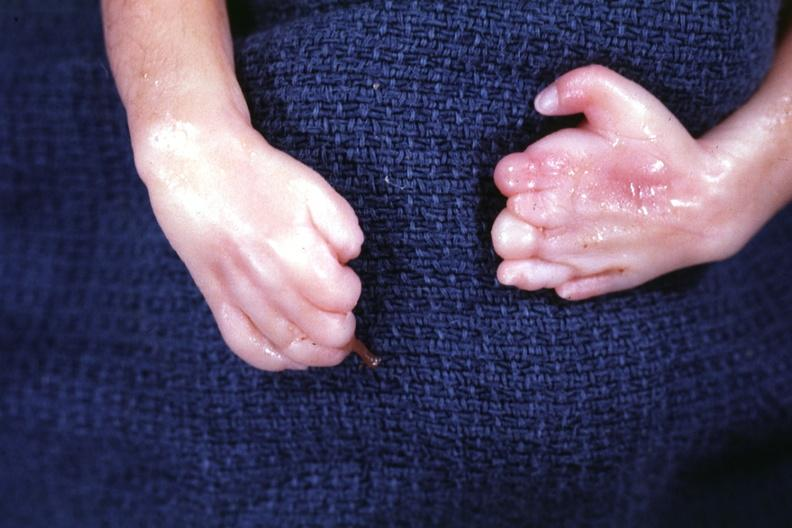what is present?
Answer the question using a single word or phrase. No 